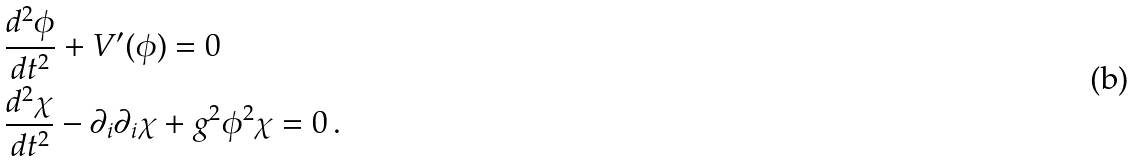<formula> <loc_0><loc_0><loc_500><loc_500>& \frac { d ^ { 2 } \phi } { d t ^ { 2 } } + V ^ { \prime } ( \phi ) = 0 \\ & \frac { d ^ { 2 } \chi } { d t ^ { 2 } } - \partial _ { i } \partial _ { i } \chi + g ^ { 2 } \phi ^ { 2 } \chi = 0 \, .</formula> 